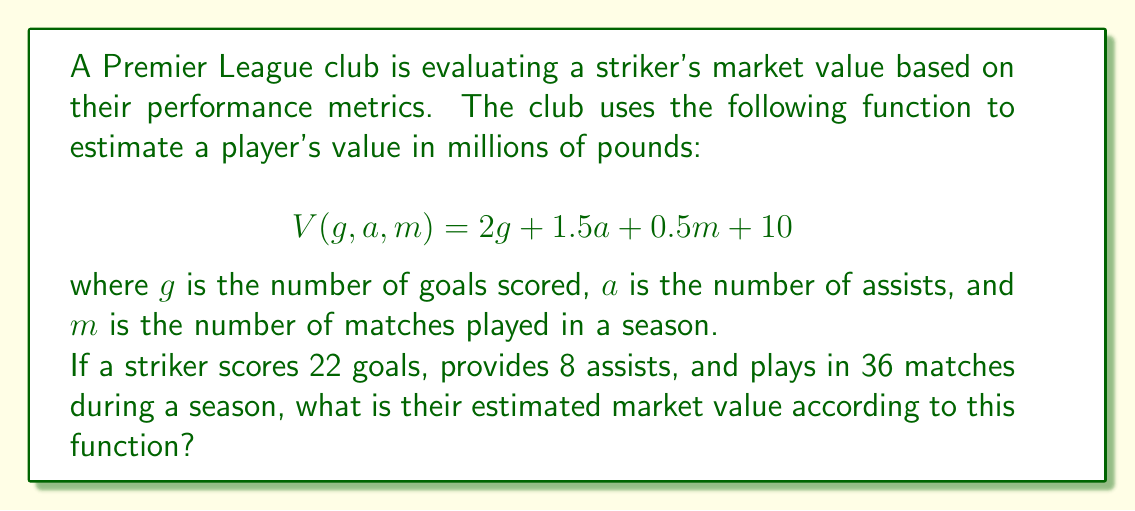What is the answer to this math problem? To solve this problem, we'll follow these steps:

1. Identify the given values:
   $g = 22$ (goals scored)
   $a = 8$ (assists provided)
   $m = 36$ (matches played)

2. Substitute these values into the given function:
   $$V(g, a, m) = 2g + 1.5a + 0.5m + 10$$

3. Calculate each term:
   - $2g = 2 \times 22 = 44$
   - $1.5a = 1.5 \times 8 = 12$
   - $0.5m = 0.5 \times 36 = 18$

4. Sum up all the terms:
   $$V(22, 8, 36) = 44 + 12 + 18 + 10$$

5. Compute the final result:
   $$V(22, 8, 36) = 84$$

Therefore, the striker's estimated market value is 84 million pounds.
Answer: £84 million 